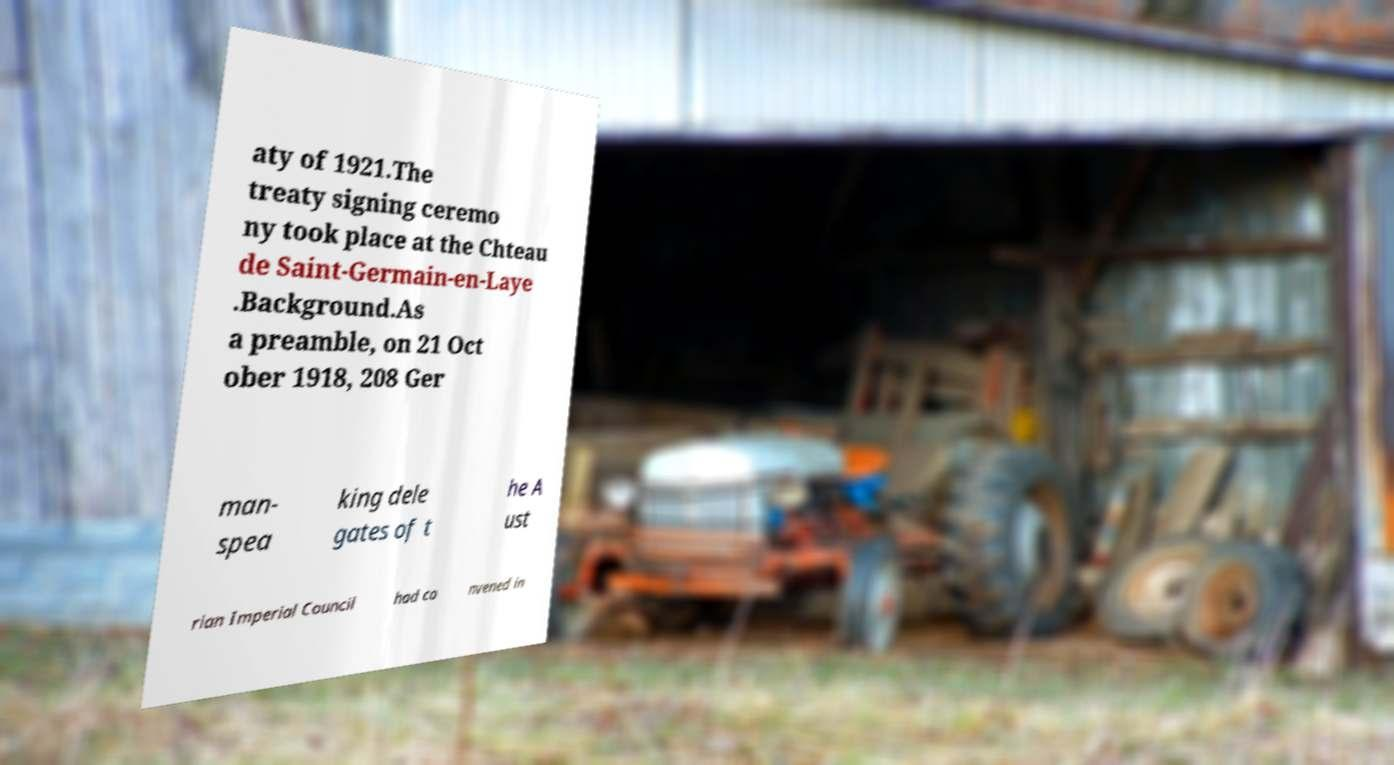What messages or text are displayed in this image? I need them in a readable, typed format. aty of 1921.The treaty signing ceremo ny took place at the Chteau de Saint-Germain-en-Laye .Background.As a preamble, on 21 Oct ober 1918, 208 Ger man- spea king dele gates of t he A ust rian Imperial Council had co nvened in 